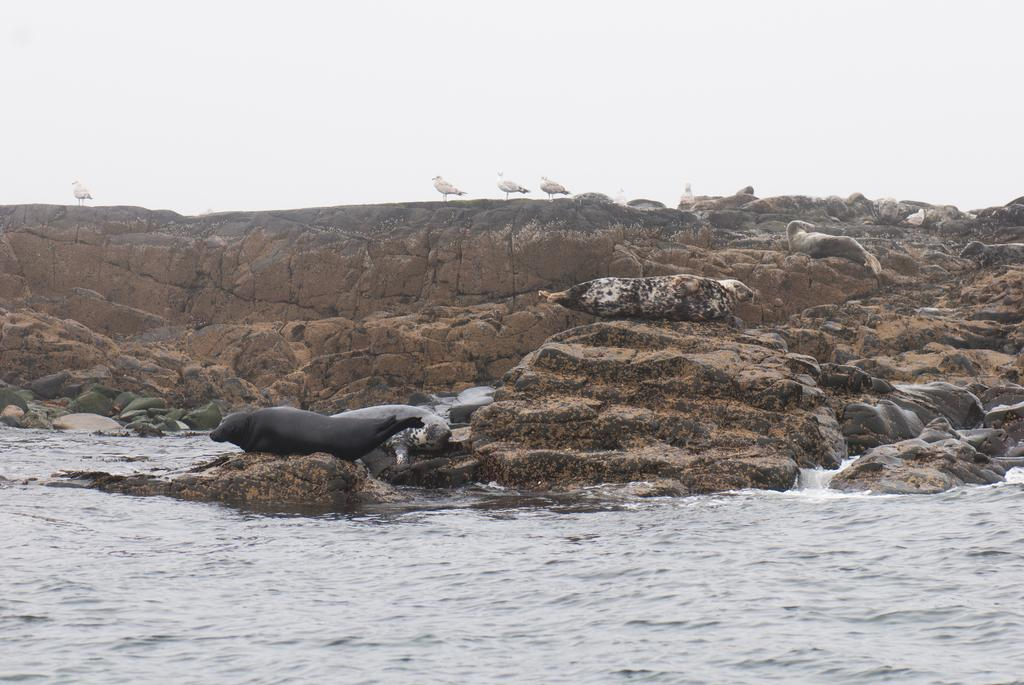What animals are on the rocks in the image? There are seals on the rocks in the image. What other creatures can be seen on the rocks? There are white birds on the rocks in the image. What type of environment is visible in the image? There is a sea visible in the image. What is the condition of the sky in the image? The sky is clear in the image. How many people have given their approval for the mass knot-tying event in the image? There is no indication of a mass knot-tying event or any people in the image. 